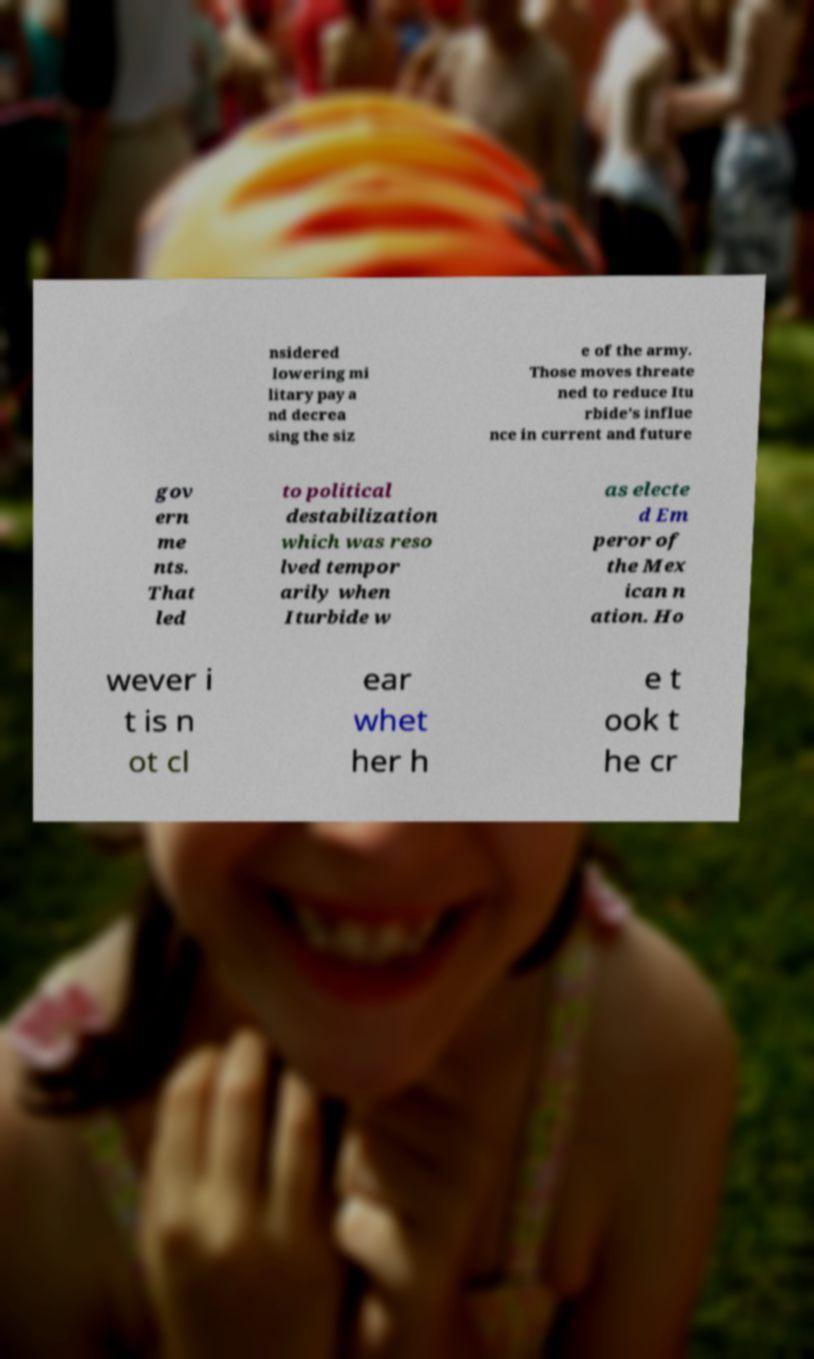Please identify and transcribe the text found in this image. nsidered lowering mi litary pay a nd decrea sing the siz e of the army. Those moves threate ned to reduce Itu rbide's influe nce in current and future gov ern me nts. That led to political destabilization which was reso lved tempor arily when Iturbide w as electe d Em peror of the Mex ican n ation. Ho wever i t is n ot cl ear whet her h e t ook t he cr 